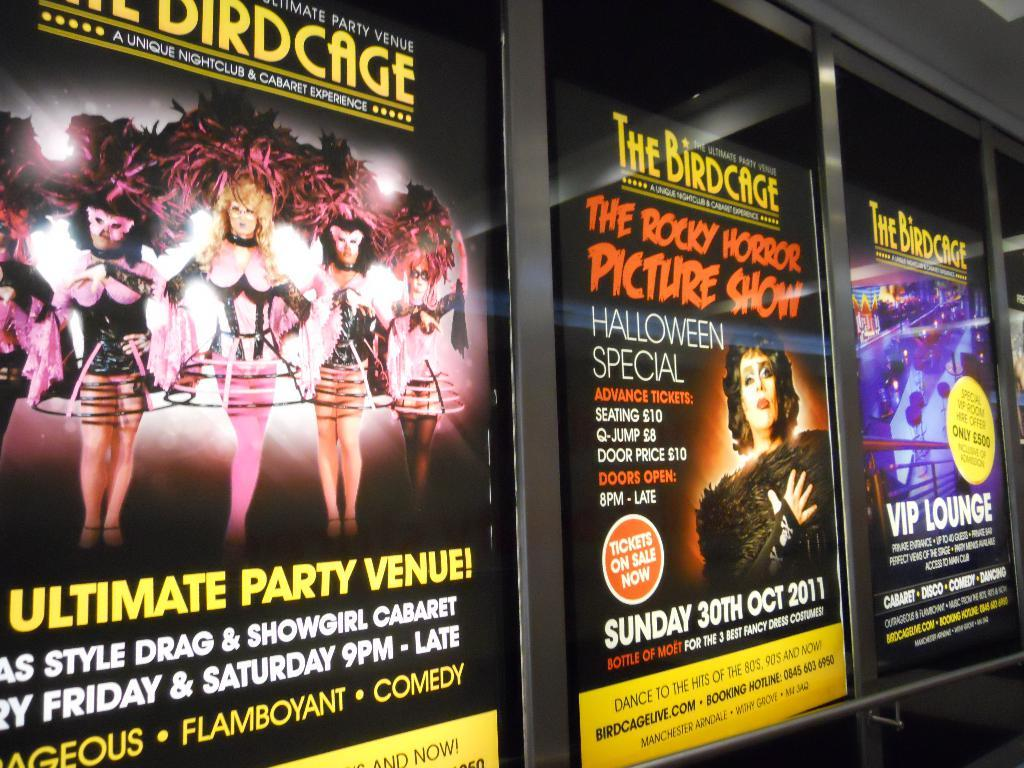<image>
Offer a succinct explanation of the picture presented. Three poster side by side with the name birdcase. 